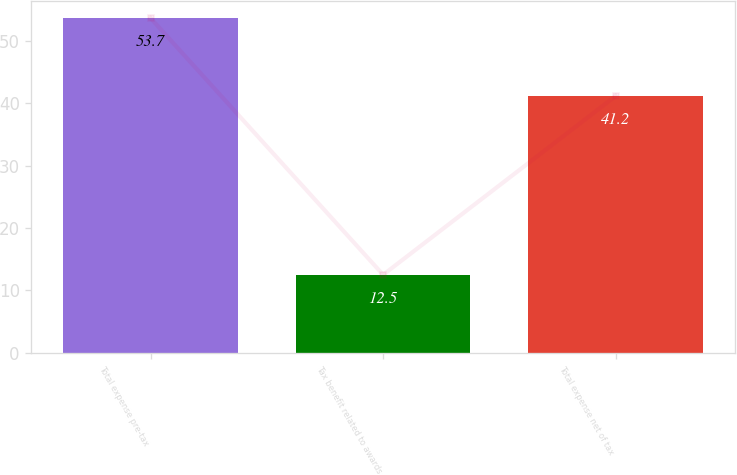Convert chart to OTSL. <chart><loc_0><loc_0><loc_500><loc_500><bar_chart><fcel>Total expense pre-tax<fcel>Tax benefit related to awards<fcel>Total expense net of tax<nl><fcel>53.7<fcel>12.5<fcel>41.2<nl></chart> 